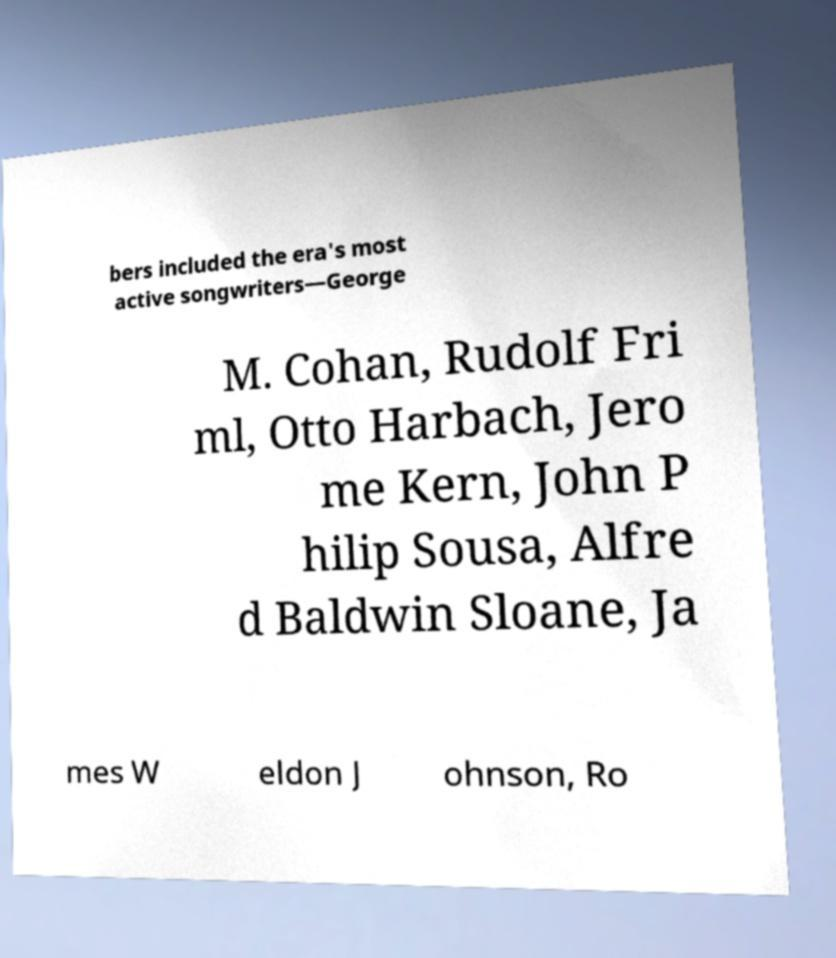I need the written content from this picture converted into text. Can you do that? bers included the era's most active songwriters—George M. Cohan, Rudolf Fri ml, Otto Harbach, Jero me Kern, John P hilip Sousa, Alfre d Baldwin Sloane, Ja mes W eldon J ohnson, Ro 